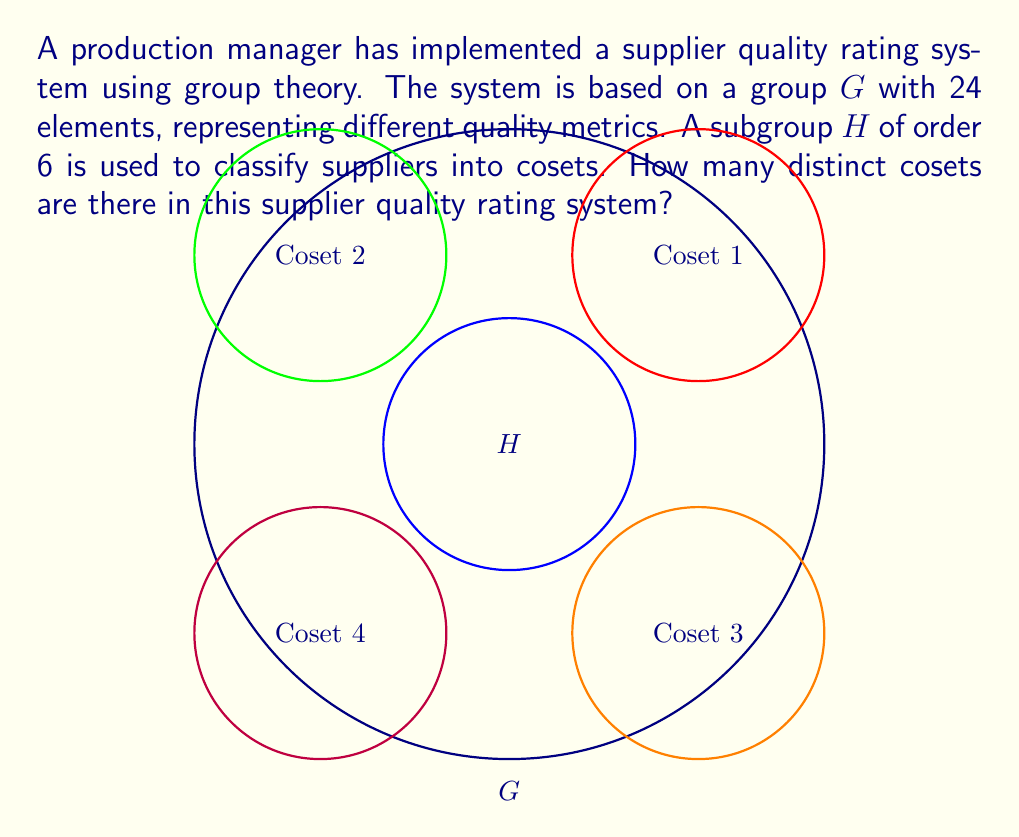Help me with this question. To determine the number of cosets in this supplier quality rating system, we'll use the following steps:

1) Recall the Lagrange's Theorem: For a finite group $G$ and a subgroup $H$ of $G$, the order of $H$ divides the order of $G$. Moreover, the number of cosets of $H$ in $G$ is equal to the index of $H$ in $G$, denoted as $[G:H]$.

2) The index $[G:H]$ is given by the formula:

   $$[G:H] = \frac{|G|}{|H|}$$

   where $|G|$ is the order of group $G$ and $|H|$ is the order of subgroup $H$.

3) In this case:
   $|G| = 24$ (the group has 24 elements)
   $|H| = 6$ (the subgroup has order 6)

4) Applying the formula:

   $$[G:H] = \frac{|G|}{|H|} = \frac{24}{6} = 4$$

5) Therefore, there are 4 distinct cosets in this supplier quality rating system.

This means that the suppliers can be classified into 4 different categories based on their quality metrics, allowing the production manager to efficiently evaluate and compare supplier performance.
Answer: 4 cosets 